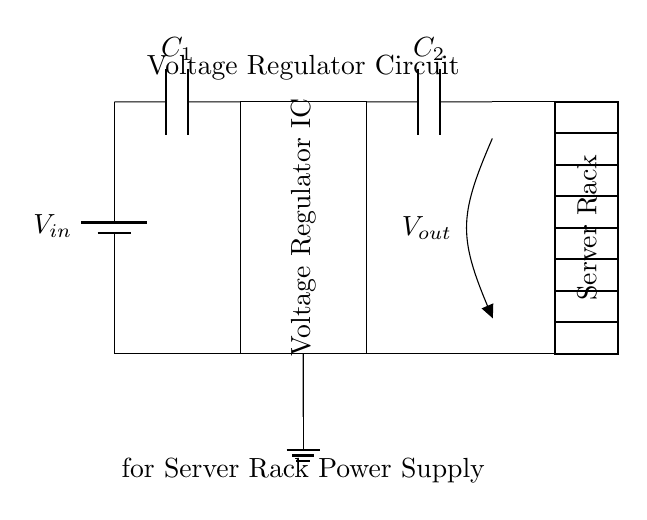What is the input voltage source represented in the circuit? The input voltage source is marked as V in the circuit diagram, found at the start of the diagram.
Answer: V in What function does the Voltage Regulator IC serve in this circuit? The Voltage Regulator IC ensures that the output voltage remains stable regardless of variations in the input voltage or load conditions, providing reliable power to the server racks.
Answer: Stabilizes voltage How are the output and ground connected in this circuit? The output, indicated as V out, is connected to the output capacitor C2 and the server rack. The ground connection for both input and output is depicted via the ground symbol below the circuit.
Answer: Through ground What are the components present in the circuit? The components include a battery (input source), two capacitors (C1, C2), and a Voltage Regulator IC.
Answer: Battery, capacitors, regulator Explain the role of output capacitor C2. Output capacitor C2 helps to smooth the output voltage by reducing voltage ripple, acting as a filter to stabilize the power supply to the server rack under varying load conditions.
Answer: Filters voltage Which component ensures stable power supply to the server racks? The component ensuring stable power supply is the Voltage Regulator IC, as its primary function is to provide consistent output voltage despite fluctuations in input or load.
Answer: Voltage Regulator IC How many capacitors are present in the circuit and what are they labeled? There are two capacitors in the circuit labeled as C1 and C2, positioned before and after the Voltage Regulator IC, respectively.
Answer: Two, labeled C1 and C2 